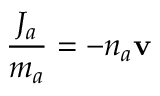<formula> <loc_0><loc_0><loc_500><loc_500>\frac { J _ { a } } { m _ { a } } = - n _ { a } v</formula> 